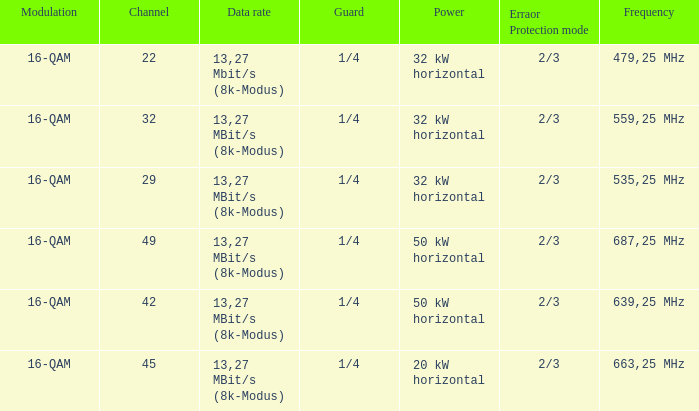On channel 32, when the power is 32 kW horizontal, what is the frequency? 559,25 MHz. 